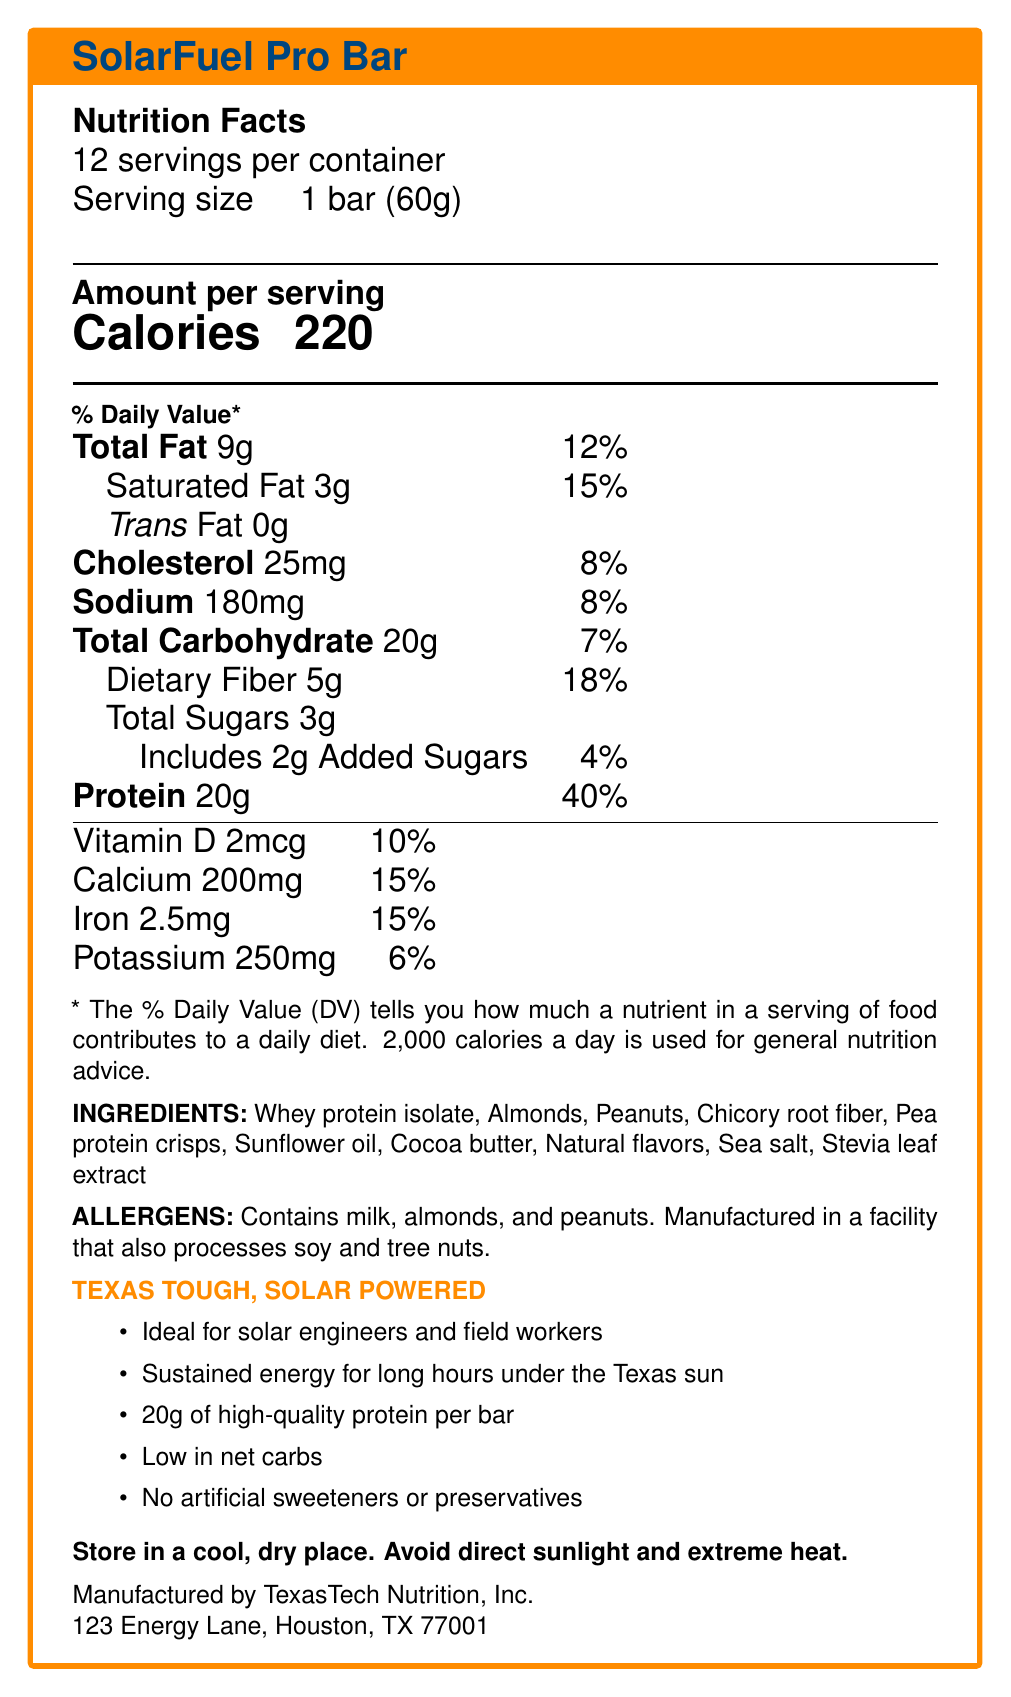What is the serving size of the SolarFuel Pro Bar? The document specifies the serving size as "1 bar (60g)" under the Nutrition Facts.
Answer: 1 bar (60g) How many servings are in one container of SolarFuel Pro Bar? The document states "12 servings per container."
Answer: 12 How many calories are there per serving? The document lists "Calories" as 220 per serving in the Nutrition Facts section.
Answer: 220 What is the percentage of daily value for protein per serving? The document lists "Protein 20g" with a daily value of "40%" in the Nutrition Facts.
Answer: 40% Which vitamin has the highest percentage daily value in the SolarFuel Pro Bar? The document lists "Calcium 15%" which is higher compared to other listed vitamins and minerals.
Answer: Calcium Does the SolarFuel Pro Bar contain any trans fat? The document specifically notes that the bar has "Trans Fat 0g".
Answer: No Which nutrient has the highest amount per serving? Based on the document, protein has 20g per serving, which is the highest among listed nutrients.
Answer: Protein What are the storage instructions for the SolarFuel Pro Bar? The document provides specific storage instructions to "Store in a cool, dry place. Avoid direct sunlight and extreme heat."
Answer: Store in a cool, dry place. Avoid direct sunlight and extreme heat. What is the daily value percentage for dietary fiber? The document lists "Dietary Fiber 5g" with a daily value of "18%".
Answer: 18% Which of the following ingredients is used as a sweetener in the SolarFuel Pro Bar?
A. Chicory root fiber 
B. Stevia leaf extract 
C. Sea salt The document lists Stevia leaf extract among the ingredients, typically used as a sweetener.
Answer: B. Stevia leaf extract How much cholesterol is in each serving? A. 5mg B. 20mg C. 25mg D. 30mg The document lists "Cholesterol 25mg" per serving.
Answer: C. 25mg Are there any nuts included in the SolarFuel Pro Bar? The document states that the bar contains almonds and peanuts, under the allergens section.
Answer: Yes What are the marketing claims made for the SolarFuel Pro Bar? The document lists these points under the marketing claims section.
Answer: Ideal for solar engineers and field workers, Sustained energy for long hours under the Texas sun, 20g of high-quality protein per bar, Low in net carbs, No artificial sweeteners or preservatives Can it be determined if the SolarFuel Pro Bar is organic based on the document? The document does not specify whether the ingredients are organic.
Answer: Not enough information Summarize the main focus of the document. The document provides details on servings, calories, nutrients, ingredients, storage instructions, allergens, and marketing claims, emphasizing its suitability for long hours of high-energy work outdoors.
Answer: The document is a Nutrition Facts Label for the SolarFuel Pro Bar, highlighting its nutritional content, ingredients, allergens, marketing claims, and manufacturer details, designed for high-protein, low-carb energy needs suitable for solar engineers and field workers. 